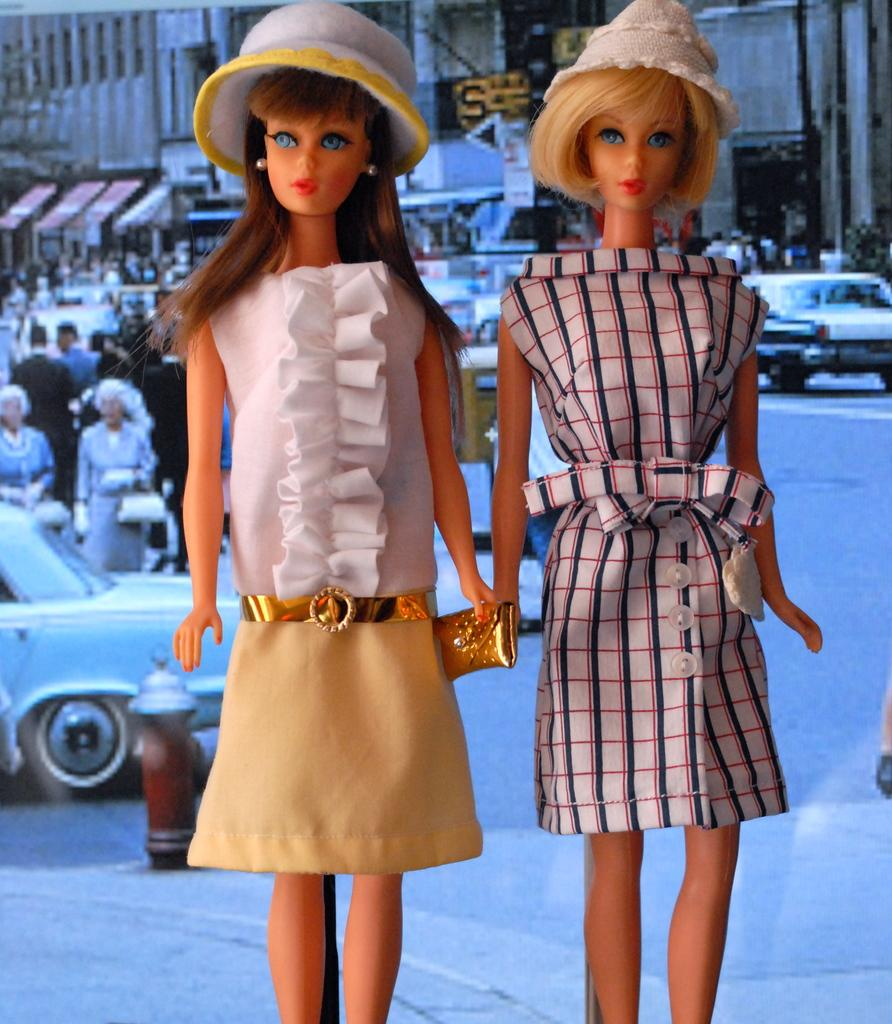What objects are in the foreground of the image? There are toys in the foreground of the image. What can be seen in the background of the image? In the background of the image, there are people, vehicles, trees, posters, stalls, and a building. Can you describe the setting of the image? The image appears to be set in an outdoor area with a variety of activities and structures visible. What type of throne is the donkey sitting on in the image? There is no donkey or throne present in the image. 